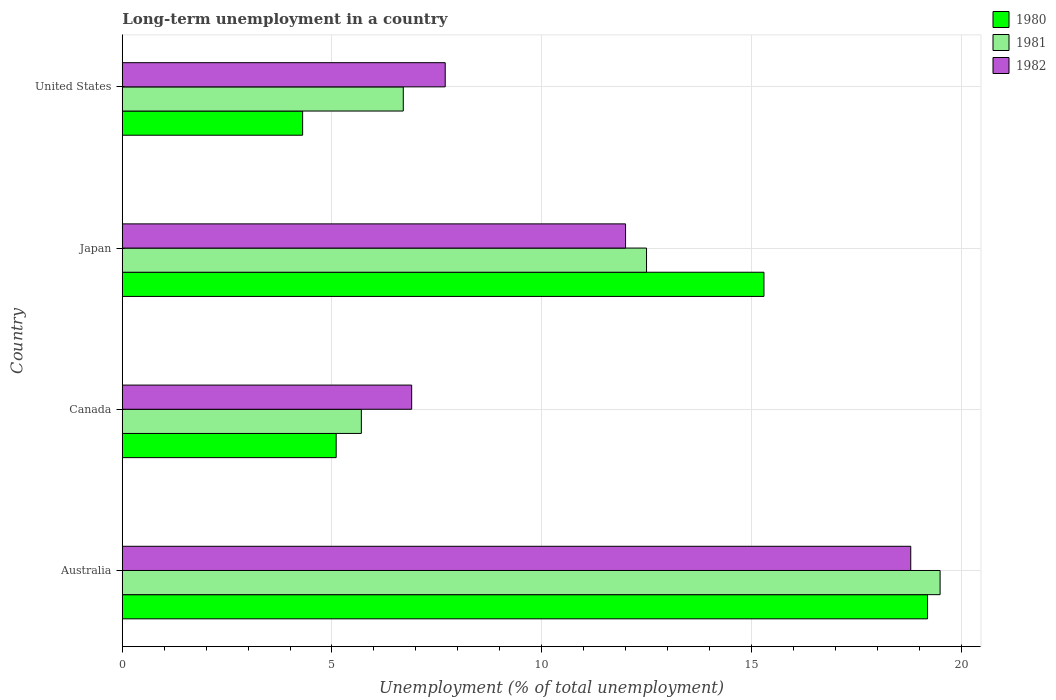How many groups of bars are there?
Give a very brief answer. 4. Are the number of bars per tick equal to the number of legend labels?
Your response must be concise. Yes. How many bars are there on the 2nd tick from the top?
Your answer should be compact. 3. What is the label of the 2nd group of bars from the top?
Make the answer very short. Japan. In how many cases, is the number of bars for a given country not equal to the number of legend labels?
Your answer should be very brief. 0. What is the percentage of long-term unemployed population in 1982 in Canada?
Your answer should be compact. 6.9. Across all countries, what is the maximum percentage of long-term unemployed population in 1982?
Ensure brevity in your answer.  18.8. Across all countries, what is the minimum percentage of long-term unemployed population in 1980?
Your answer should be very brief. 4.3. What is the total percentage of long-term unemployed population in 1982 in the graph?
Ensure brevity in your answer.  45.4. What is the difference between the percentage of long-term unemployed population in 1981 in Australia and that in United States?
Offer a terse response. 12.8. What is the difference between the percentage of long-term unemployed population in 1980 in United States and the percentage of long-term unemployed population in 1981 in Australia?
Your response must be concise. -15.2. What is the average percentage of long-term unemployed population in 1980 per country?
Offer a terse response. 10.98. What is the difference between the percentage of long-term unemployed population in 1981 and percentage of long-term unemployed population in 1982 in Australia?
Your answer should be compact. 0.7. What is the ratio of the percentage of long-term unemployed population in 1981 in Australia to that in United States?
Provide a short and direct response. 2.91. What is the difference between the highest and the second highest percentage of long-term unemployed population in 1982?
Offer a very short reply. 6.8. What is the difference between the highest and the lowest percentage of long-term unemployed population in 1982?
Make the answer very short. 11.9. In how many countries, is the percentage of long-term unemployed population in 1980 greater than the average percentage of long-term unemployed population in 1980 taken over all countries?
Provide a succinct answer. 2. Is the sum of the percentage of long-term unemployed population in 1980 in Australia and United States greater than the maximum percentage of long-term unemployed population in 1981 across all countries?
Provide a short and direct response. Yes. What does the 3rd bar from the bottom in Canada represents?
Provide a succinct answer. 1982. Is it the case that in every country, the sum of the percentage of long-term unemployed population in 1981 and percentage of long-term unemployed population in 1982 is greater than the percentage of long-term unemployed population in 1980?
Your answer should be very brief. Yes. How many bars are there?
Your answer should be very brief. 12. Are the values on the major ticks of X-axis written in scientific E-notation?
Your answer should be compact. No. Does the graph contain any zero values?
Offer a very short reply. No. Does the graph contain grids?
Keep it short and to the point. Yes. What is the title of the graph?
Ensure brevity in your answer.  Long-term unemployment in a country. What is the label or title of the X-axis?
Offer a terse response. Unemployment (% of total unemployment). What is the label or title of the Y-axis?
Provide a succinct answer. Country. What is the Unemployment (% of total unemployment) of 1980 in Australia?
Provide a short and direct response. 19.2. What is the Unemployment (% of total unemployment) of 1982 in Australia?
Your response must be concise. 18.8. What is the Unemployment (% of total unemployment) of 1980 in Canada?
Offer a terse response. 5.1. What is the Unemployment (% of total unemployment) of 1981 in Canada?
Provide a short and direct response. 5.7. What is the Unemployment (% of total unemployment) in 1982 in Canada?
Your answer should be compact. 6.9. What is the Unemployment (% of total unemployment) of 1980 in Japan?
Make the answer very short. 15.3. What is the Unemployment (% of total unemployment) in 1981 in Japan?
Provide a succinct answer. 12.5. What is the Unemployment (% of total unemployment) of 1982 in Japan?
Offer a terse response. 12. What is the Unemployment (% of total unemployment) in 1980 in United States?
Provide a succinct answer. 4.3. What is the Unemployment (% of total unemployment) of 1981 in United States?
Make the answer very short. 6.7. What is the Unemployment (% of total unemployment) of 1982 in United States?
Offer a very short reply. 7.7. Across all countries, what is the maximum Unemployment (% of total unemployment) in 1980?
Provide a short and direct response. 19.2. Across all countries, what is the maximum Unemployment (% of total unemployment) of 1981?
Give a very brief answer. 19.5. Across all countries, what is the maximum Unemployment (% of total unemployment) of 1982?
Your answer should be very brief. 18.8. Across all countries, what is the minimum Unemployment (% of total unemployment) in 1980?
Your answer should be very brief. 4.3. Across all countries, what is the minimum Unemployment (% of total unemployment) of 1981?
Your answer should be very brief. 5.7. Across all countries, what is the minimum Unemployment (% of total unemployment) of 1982?
Provide a short and direct response. 6.9. What is the total Unemployment (% of total unemployment) of 1980 in the graph?
Keep it short and to the point. 43.9. What is the total Unemployment (% of total unemployment) in 1981 in the graph?
Give a very brief answer. 44.4. What is the total Unemployment (% of total unemployment) in 1982 in the graph?
Keep it short and to the point. 45.4. What is the difference between the Unemployment (% of total unemployment) in 1980 in Australia and that in Canada?
Offer a terse response. 14.1. What is the difference between the Unemployment (% of total unemployment) of 1982 in Australia and that in Canada?
Provide a short and direct response. 11.9. What is the difference between the Unemployment (% of total unemployment) of 1980 in Australia and that in Japan?
Give a very brief answer. 3.9. What is the difference between the Unemployment (% of total unemployment) of 1981 in Australia and that in Japan?
Give a very brief answer. 7. What is the difference between the Unemployment (% of total unemployment) of 1982 in Australia and that in Japan?
Your answer should be compact. 6.8. What is the difference between the Unemployment (% of total unemployment) in 1980 in Canada and that in Japan?
Give a very brief answer. -10.2. What is the difference between the Unemployment (% of total unemployment) of 1982 in Canada and that in Japan?
Provide a succinct answer. -5.1. What is the difference between the Unemployment (% of total unemployment) in 1980 in Canada and that in United States?
Give a very brief answer. 0.8. What is the difference between the Unemployment (% of total unemployment) in 1981 in Canada and that in United States?
Make the answer very short. -1. What is the difference between the Unemployment (% of total unemployment) in 1982 in Canada and that in United States?
Your response must be concise. -0.8. What is the difference between the Unemployment (% of total unemployment) of 1981 in Japan and that in United States?
Keep it short and to the point. 5.8. What is the difference between the Unemployment (% of total unemployment) of 1982 in Japan and that in United States?
Provide a short and direct response. 4.3. What is the difference between the Unemployment (% of total unemployment) of 1980 in Australia and the Unemployment (% of total unemployment) of 1982 in Japan?
Your response must be concise. 7.2. What is the difference between the Unemployment (% of total unemployment) of 1981 in Australia and the Unemployment (% of total unemployment) of 1982 in Japan?
Offer a terse response. 7.5. What is the difference between the Unemployment (% of total unemployment) of 1980 in Australia and the Unemployment (% of total unemployment) of 1982 in United States?
Offer a very short reply. 11.5. What is the difference between the Unemployment (% of total unemployment) of 1981 in Australia and the Unemployment (% of total unemployment) of 1982 in United States?
Keep it short and to the point. 11.8. What is the difference between the Unemployment (% of total unemployment) of 1980 in Canada and the Unemployment (% of total unemployment) of 1981 in Japan?
Your answer should be compact. -7.4. What is the difference between the Unemployment (% of total unemployment) of 1980 in Canada and the Unemployment (% of total unemployment) of 1982 in Japan?
Ensure brevity in your answer.  -6.9. What is the average Unemployment (% of total unemployment) in 1980 per country?
Your response must be concise. 10.97. What is the average Unemployment (% of total unemployment) in 1981 per country?
Give a very brief answer. 11.1. What is the average Unemployment (% of total unemployment) of 1982 per country?
Provide a succinct answer. 11.35. What is the difference between the Unemployment (% of total unemployment) in 1980 and Unemployment (% of total unemployment) in 1981 in Australia?
Ensure brevity in your answer.  -0.3. What is the difference between the Unemployment (% of total unemployment) in 1981 and Unemployment (% of total unemployment) in 1982 in Australia?
Make the answer very short. 0.7. What is the difference between the Unemployment (% of total unemployment) in 1981 and Unemployment (% of total unemployment) in 1982 in Canada?
Give a very brief answer. -1.2. What is the difference between the Unemployment (% of total unemployment) of 1981 and Unemployment (% of total unemployment) of 1982 in Japan?
Offer a very short reply. 0.5. What is the ratio of the Unemployment (% of total unemployment) of 1980 in Australia to that in Canada?
Your answer should be compact. 3.76. What is the ratio of the Unemployment (% of total unemployment) in 1981 in Australia to that in Canada?
Offer a very short reply. 3.42. What is the ratio of the Unemployment (% of total unemployment) in 1982 in Australia to that in Canada?
Offer a terse response. 2.72. What is the ratio of the Unemployment (% of total unemployment) of 1980 in Australia to that in Japan?
Give a very brief answer. 1.25. What is the ratio of the Unemployment (% of total unemployment) in 1981 in Australia to that in Japan?
Your response must be concise. 1.56. What is the ratio of the Unemployment (% of total unemployment) in 1982 in Australia to that in Japan?
Ensure brevity in your answer.  1.57. What is the ratio of the Unemployment (% of total unemployment) in 1980 in Australia to that in United States?
Make the answer very short. 4.47. What is the ratio of the Unemployment (% of total unemployment) of 1981 in Australia to that in United States?
Provide a short and direct response. 2.91. What is the ratio of the Unemployment (% of total unemployment) of 1982 in Australia to that in United States?
Keep it short and to the point. 2.44. What is the ratio of the Unemployment (% of total unemployment) of 1981 in Canada to that in Japan?
Your response must be concise. 0.46. What is the ratio of the Unemployment (% of total unemployment) in 1982 in Canada to that in Japan?
Ensure brevity in your answer.  0.57. What is the ratio of the Unemployment (% of total unemployment) in 1980 in Canada to that in United States?
Give a very brief answer. 1.19. What is the ratio of the Unemployment (% of total unemployment) in 1981 in Canada to that in United States?
Ensure brevity in your answer.  0.85. What is the ratio of the Unemployment (% of total unemployment) of 1982 in Canada to that in United States?
Ensure brevity in your answer.  0.9. What is the ratio of the Unemployment (% of total unemployment) of 1980 in Japan to that in United States?
Offer a very short reply. 3.56. What is the ratio of the Unemployment (% of total unemployment) in 1981 in Japan to that in United States?
Provide a succinct answer. 1.87. What is the ratio of the Unemployment (% of total unemployment) in 1982 in Japan to that in United States?
Provide a succinct answer. 1.56. What is the difference between the highest and the second highest Unemployment (% of total unemployment) in 1980?
Make the answer very short. 3.9. What is the difference between the highest and the second highest Unemployment (% of total unemployment) in 1982?
Provide a succinct answer. 6.8. What is the difference between the highest and the lowest Unemployment (% of total unemployment) in 1980?
Keep it short and to the point. 14.9. 